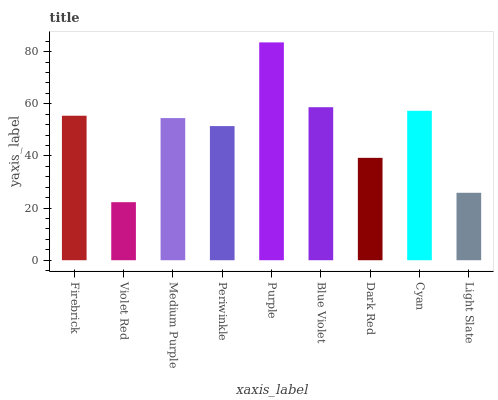Is Violet Red the minimum?
Answer yes or no. Yes. Is Purple the maximum?
Answer yes or no. Yes. Is Medium Purple the minimum?
Answer yes or no. No. Is Medium Purple the maximum?
Answer yes or no. No. Is Medium Purple greater than Violet Red?
Answer yes or no. Yes. Is Violet Red less than Medium Purple?
Answer yes or no. Yes. Is Violet Red greater than Medium Purple?
Answer yes or no. No. Is Medium Purple less than Violet Red?
Answer yes or no. No. Is Medium Purple the high median?
Answer yes or no. Yes. Is Medium Purple the low median?
Answer yes or no. Yes. Is Cyan the high median?
Answer yes or no. No. Is Violet Red the low median?
Answer yes or no. No. 